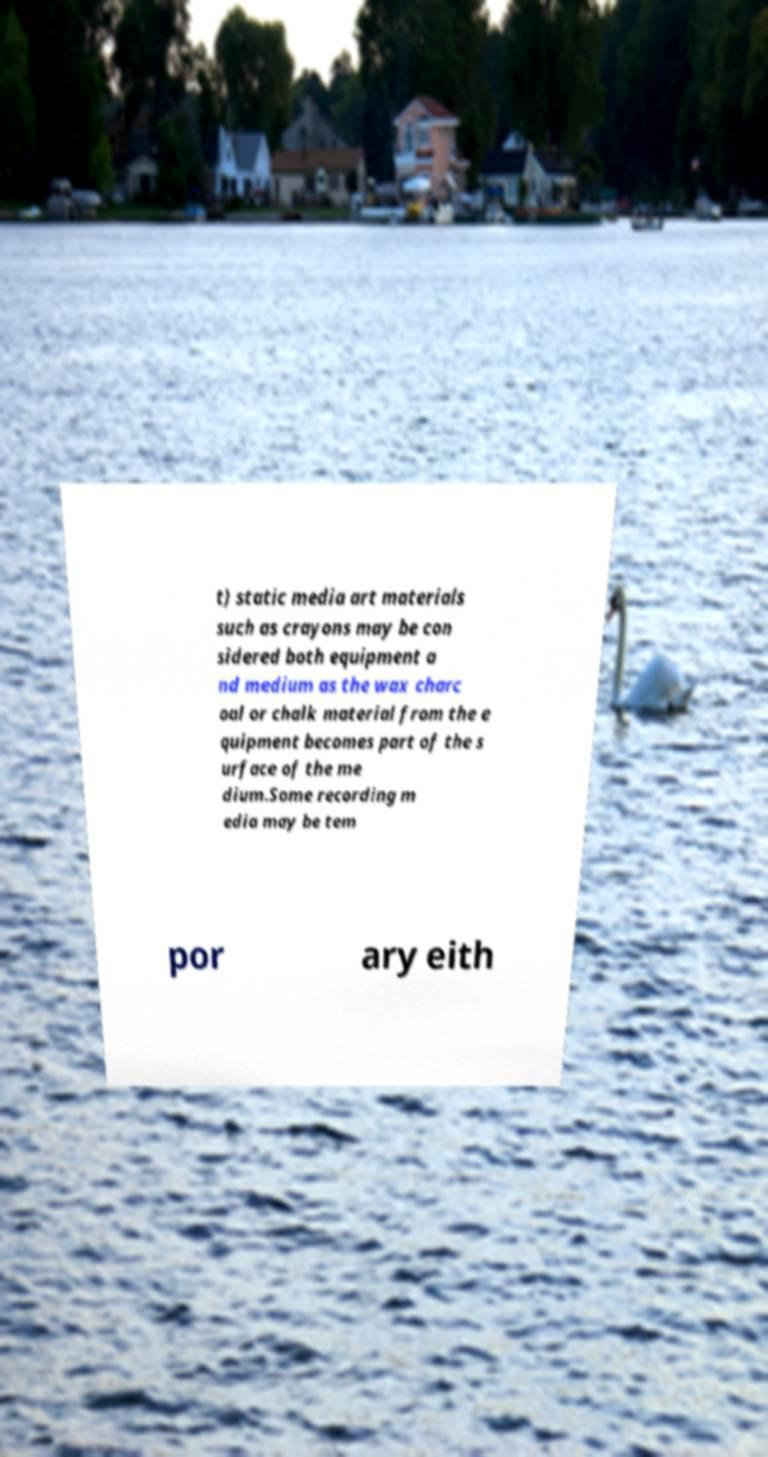Can you read and provide the text displayed in the image?This photo seems to have some interesting text. Can you extract and type it out for me? t) static media art materials such as crayons may be con sidered both equipment a nd medium as the wax charc oal or chalk material from the e quipment becomes part of the s urface of the me dium.Some recording m edia may be tem por ary eith 